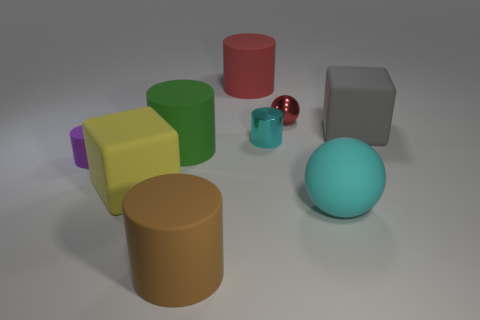Is there any indication of the light source direction in the scene? Yes, the shadows and highlights on the objects suggest that there is a light source situated towards the upper left side of the image. This is evident from the shadows cast towards the right and slightly behind the objects, which allows us to deduce the general direction from which the light is shining. 